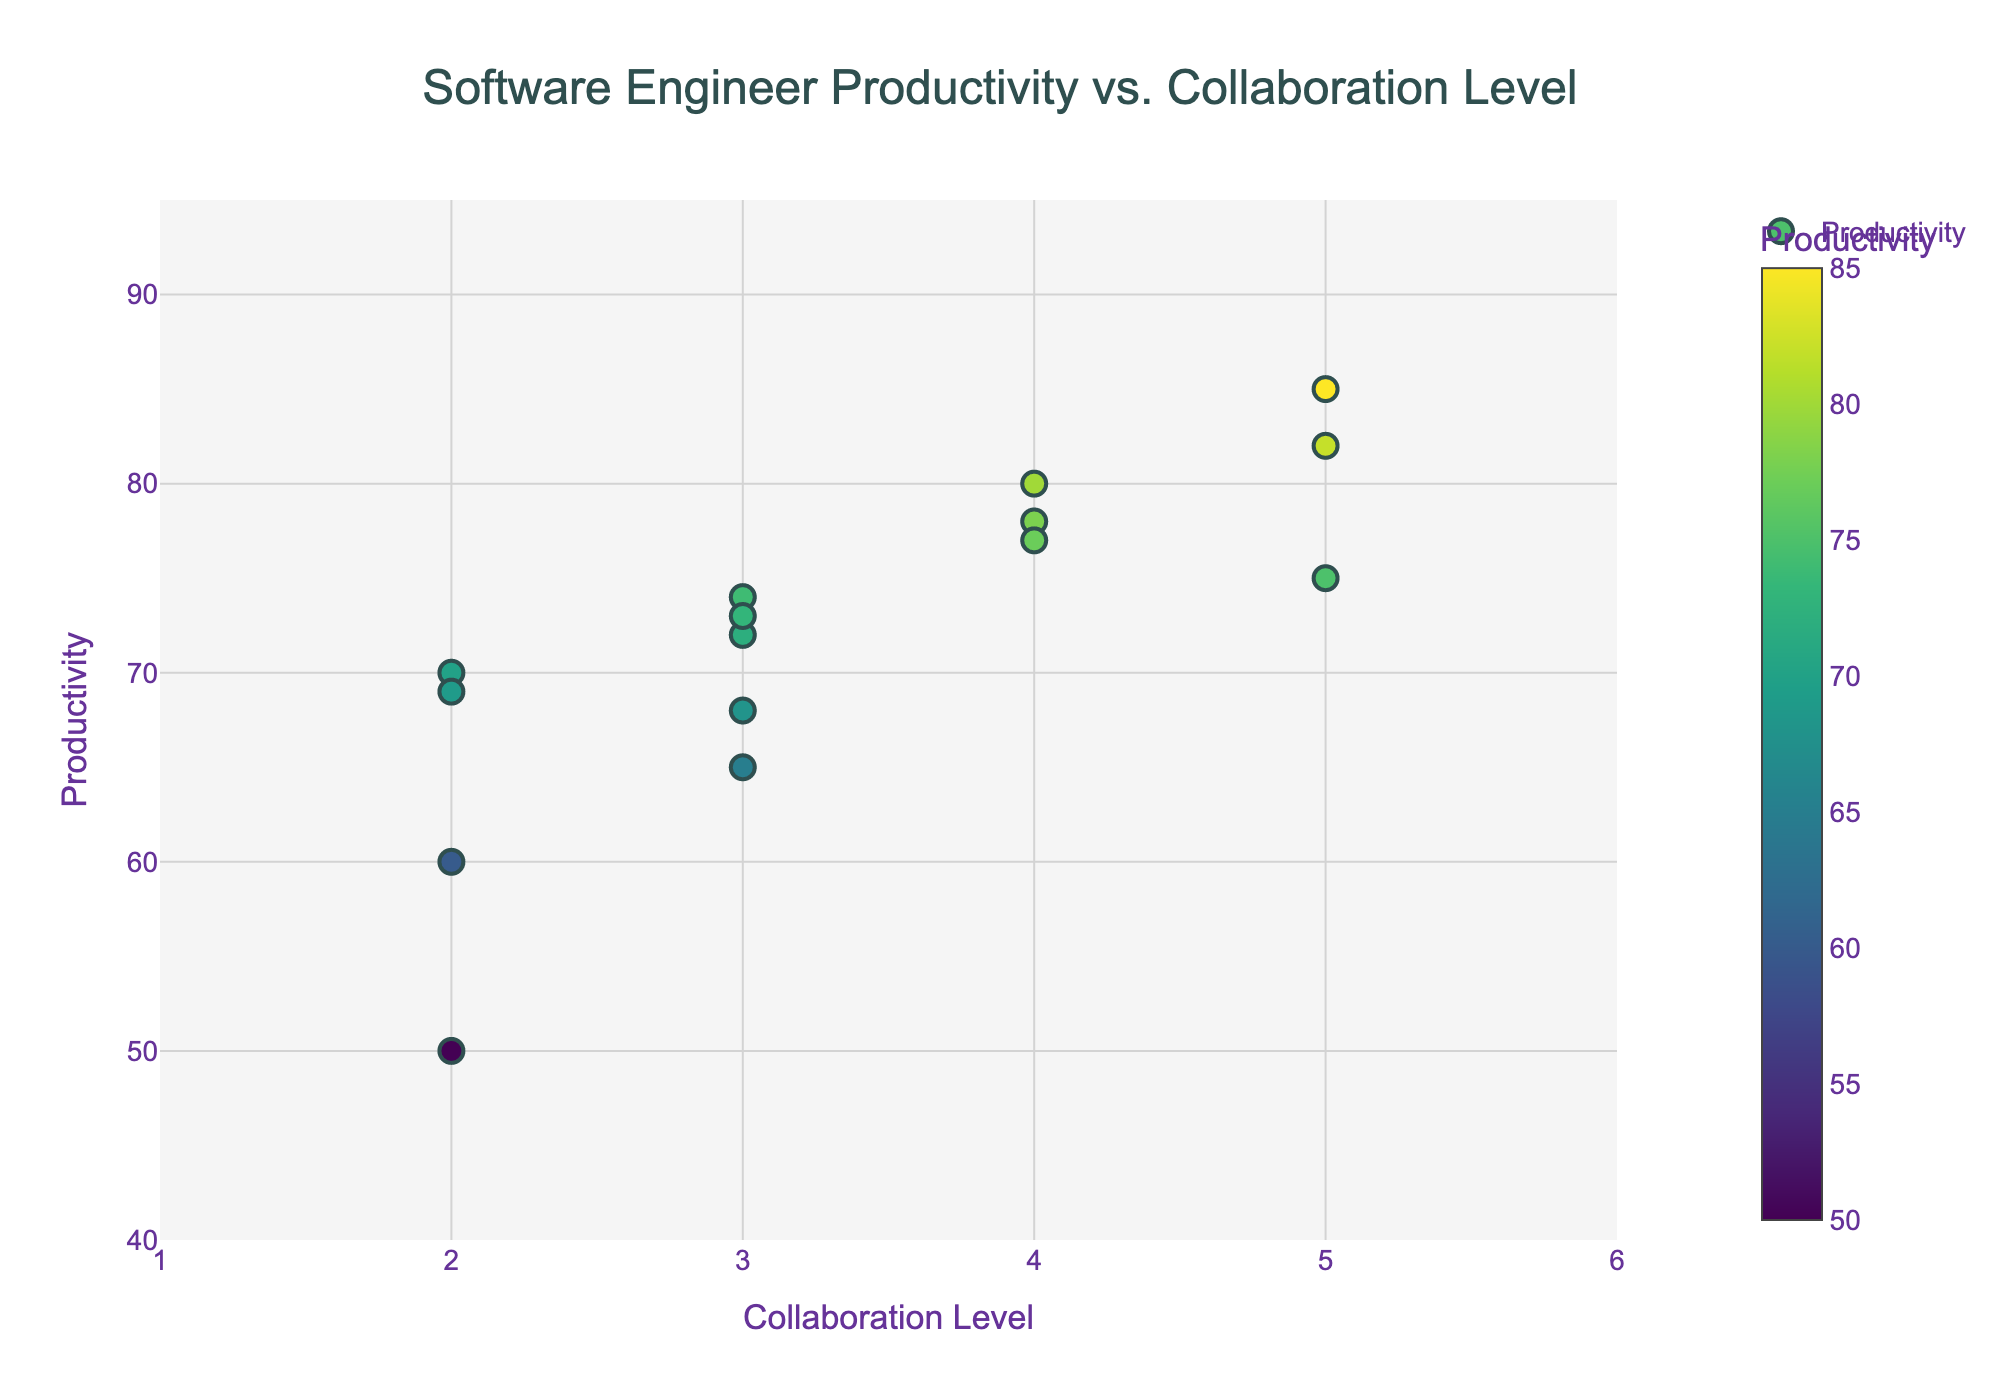What is the title of the plot? The title of the plot is situated at the top center and plainly states what the figure represents.
Answer: Software Engineer Productivity vs. Collaboration Level How many data points are shown in the figure? To find the number of data points, count each unique marker representing a software engineer. The plot has one marker per engineer in the data.
Answer: 15 Which engineer has the highest productivity and what is their collaboration level? Identify the point with the highest y-value (Productivity) in the scatter plot and note the corresponding x-value (Collaboration Level). The engineer's name is in the hover information.
Answer: Hiroshi Tanaka with a collaboration level of 5 Describe the productivity of Igor Petrov in terms of collaboration level and confidence intervals. Locate Igor Petrov's data point. He has a collaboration level of 2, productivity of 50, a lower confidence interval of 45, and an upper confidence interval of 55.
Answer: Collaboration level of 2, productivity of 50, lower CI of 45, upper CI of 55 What is the productivity range observed in the data? Determine the lowest and highest y-values (Productivity) among the data points. The minimum productivity is 50, and the maximum is 85.
Answer: 50 to 85 Which country has the most engineers in the plot? Check the hover information for each marker to identify the countries. Count the occurrences for each country.
Answer: No country has more than one engineer Who has the widest confidence interval in productivity? Look for the data point with the largest distance between the upper and lower confidence intervals, calculated from the error bars.
Answer: Nina Müller with a range of 10 (87-77) What is the average productivity for engineers with a collaboration level of 3? Identify data points where the Collaboration Level is 3, sum their Productivities, and divide by the number of such engineers. (65 + 72 + 68 + 74 + 73) / 5 = 70.4
Answer: 70.4 Which engineer's productivity is closest to the mean productivity of the whole group? Calculate the average productivity of all engineers, then find the engineer whose productivity is closest to this value. Average productivity is (75+65+80+70+85+50+78+72+68+82+60+74+77+69+73) / 15 = 71.9. Rajesh Kumar with a productivity of 77 is closest.
Answer: Rajesh Kumar How does the productivity vary across different collaboration levels? Observe the scatter plot to see how productivity points are distributed across different collaboration levels on the x-axis. Summarize any trends or patterns. Productivity seems to generally increase with higher collaboration levels, with some variability in each level.
Answer: Increases with higher collaboration levels 